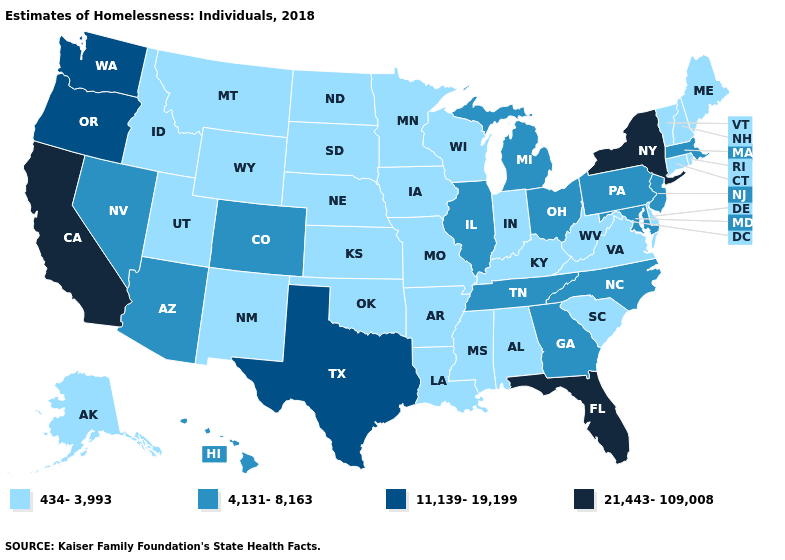Name the states that have a value in the range 4,131-8,163?
Write a very short answer. Arizona, Colorado, Georgia, Hawaii, Illinois, Maryland, Massachusetts, Michigan, Nevada, New Jersey, North Carolina, Ohio, Pennsylvania, Tennessee. What is the value of Illinois?
Write a very short answer. 4,131-8,163. Does West Virginia have a higher value than Wyoming?
Concise answer only. No. What is the value of Wisconsin?
Answer briefly. 434-3,993. Does the first symbol in the legend represent the smallest category?
Keep it brief. Yes. Does Wyoming have the highest value in the West?
Quick response, please. No. What is the value of New York?
Quick response, please. 21,443-109,008. Name the states that have a value in the range 21,443-109,008?
Keep it brief. California, Florida, New York. What is the value of Mississippi?
Be succinct. 434-3,993. What is the value of New Jersey?
Be succinct. 4,131-8,163. Name the states that have a value in the range 11,139-19,199?
Give a very brief answer. Oregon, Texas, Washington. Name the states that have a value in the range 4,131-8,163?
Short answer required. Arizona, Colorado, Georgia, Hawaii, Illinois, Maryland, Massachusetts, Michigan, Nevada, New Jersey, North Carolina, Ohio, Pennsylvania, Tennessee. Does Idaho have a lower value than Montana?
Keep it brief. No. What is the value of Ohio?
Give a very brief answer. 4,131-8,163. Which states hav the highest value in the Northeast?
Quick response, please. New York. 